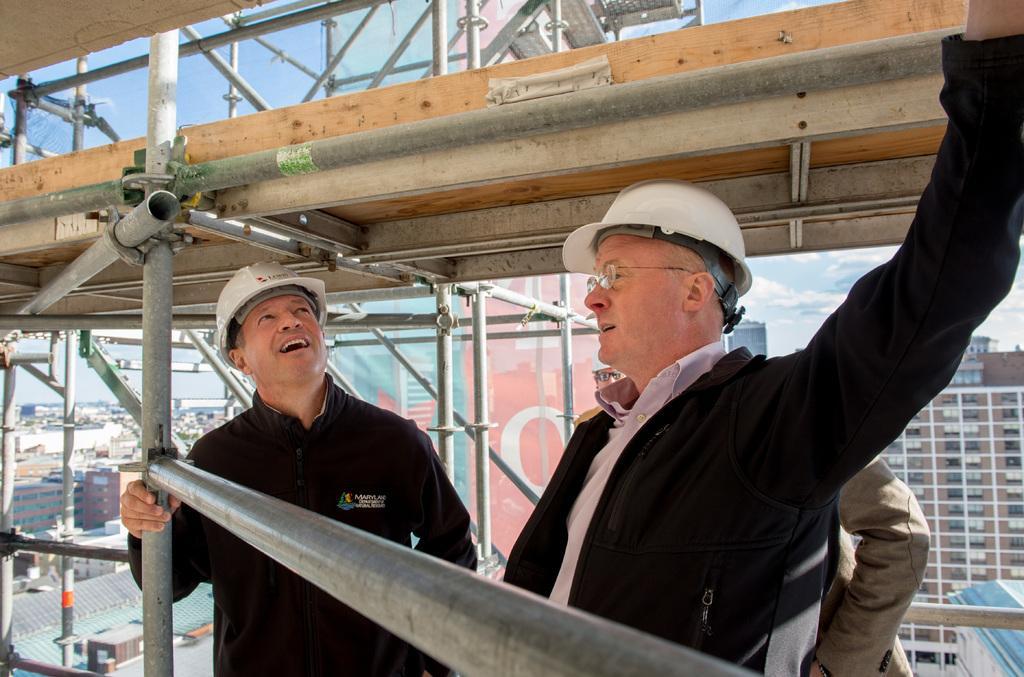In one or two sentences, can you explain what this image depicts? This image consists of three men. In the front, the two men are wearing black jackets and white helmets. In the background, there are many buildings. In the front, we can see the iron rods. At the top, there is sky. 